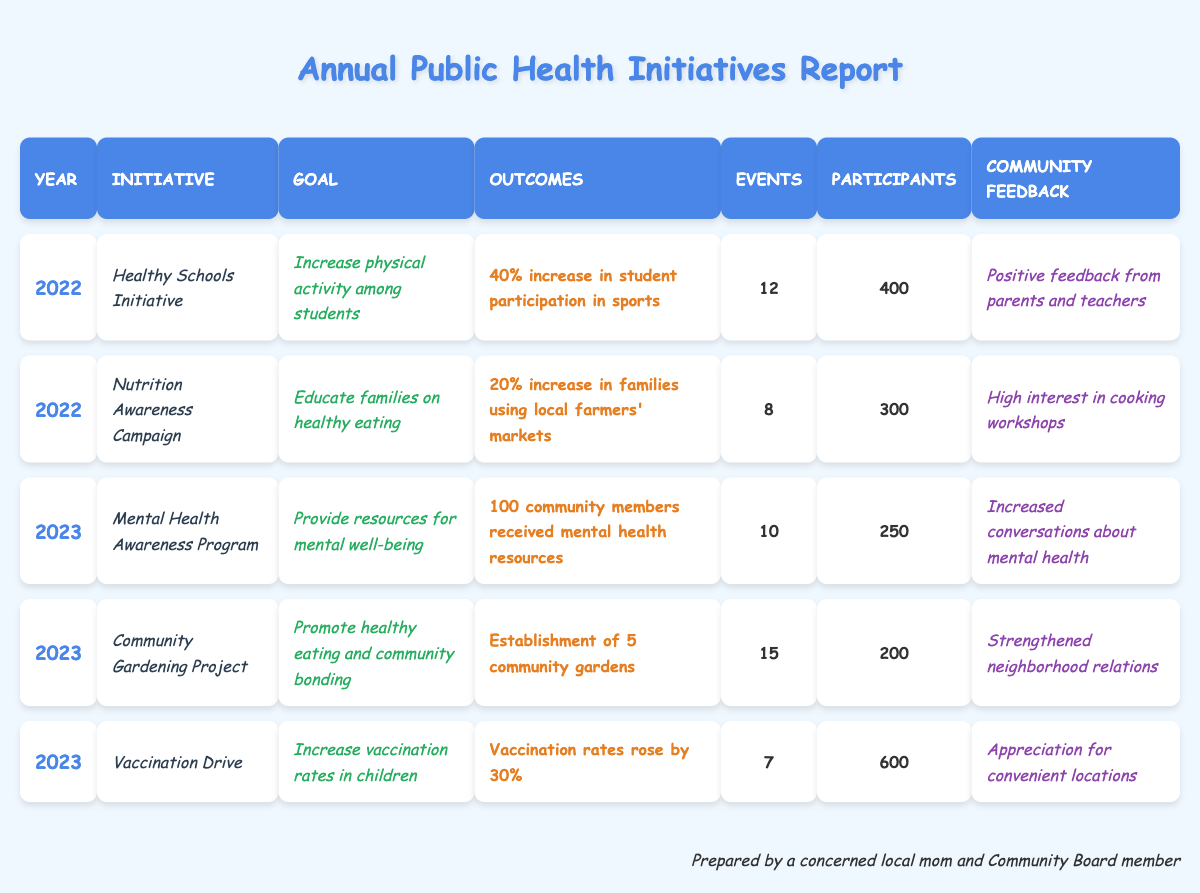What was the goal of the "Healthy Schools Initiative"? The goal, as stated in the table, is to "Increase physical activity among students."
Answer: Increase physical activity among students How many participants were involved in the "Nutrition Awareness Campaign"? Referring to the table, the "Nutrition Awareness Campaign" had 300 participants.
Answer: 300 participants What was the outcome of the "Vaccination Drive"? The table shows that the vaccination rates rose by 30% as a result of the "Vaccination Drive."
Answer: Vaccination rates rose by 30% Which initiative had the highest number of events in 2023? By reviewing the events per initiative in 2023, the "Community Gardening Project" had 15 events, which is the highest.
Answer: Community Gardening Project What percentage increase in student participation was reported for the "Healthy Schools Initiative"? The reported outcome for the initiative indicates a 40% increase in student participation in sports.
Answer: 40% How many community members received mental health resources in 2023? The table provides information that 100 community members received mental health resources during the "Mental Health Awareness Program."
Answer: 100 community members What was the total number of events held for all initiatives in 2022? Adding the number of events in 2022: 12 (Healthy Schools) + 8 (Nutrition Awareness) = 20 total events.
Answer: 20 events Did the "Community Gardening Project" receive positive feedback? The feedback for the "Community Gardening Project" states it strengthened neighborhood relations; therefore, it can be inferred as positive.
Answer: Yes What percentage increase in families using local farmers' markets was achieved through the "Nutrition Awareness Campaign"? The table indicates a 20% increase in families using local farmers' markets due to the campaign.
Answer: 20% How many more participants were engaged in the "Vaccination Drive" compared to the "Mental Health Awareness Program"? The difference in participants is calculated as 600 (Vaccination Drive) - 250 (Mental Health Program) = 350.
Answer: 350 participants 